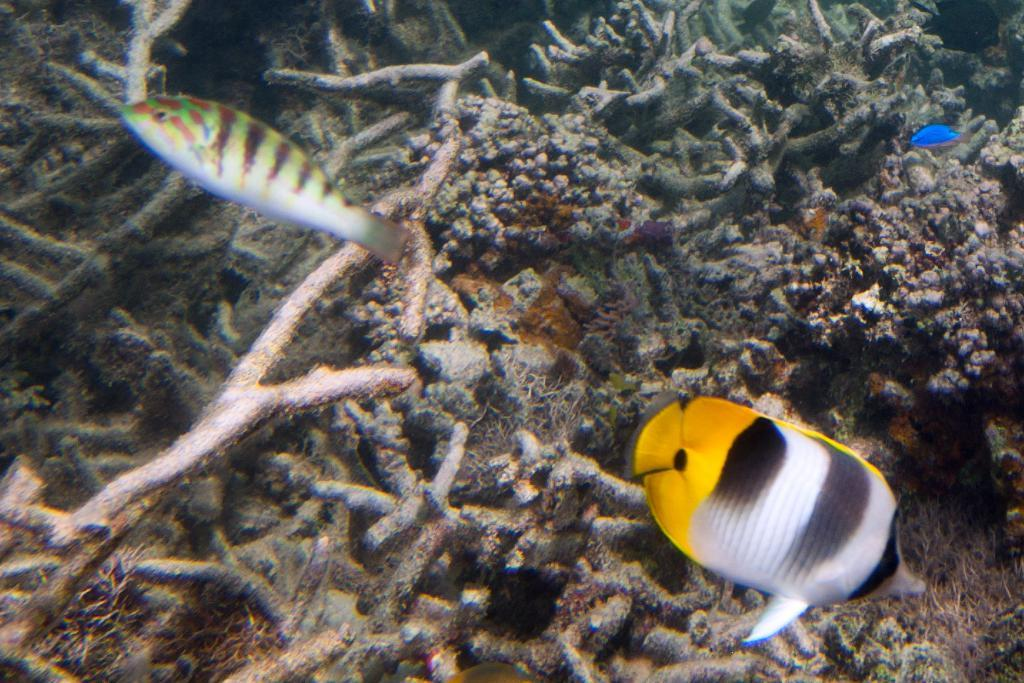What type of animals are present in the image? There are fishes in the image. Where are the fishes located? The fishes are in an aquarium. What type of fiction is the fishes reading in the image? The fishes are not reading any fiction in the image, as they are aquatic animals and do not have the ability to read. 